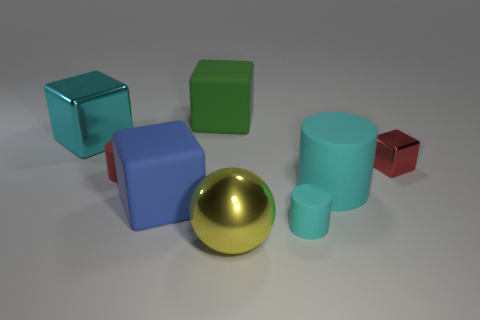Subtract all big blue rubber blocks. How many blocks are left? 3 Add 1 cyan metallic blocks. How many objects exist? 9 Subtract 1 balls. How many balls are left? 0 Subtract all cyan cubes. How many cubes are left? 3 Subtract all cylinders. How many objects are left? 5 Subtract all green blocks. How many cyan cylinders are left? 2 Add 1 blue rubber blocks. How many blue rubber blocks exist? 2 Subtract 0 purple cubes. How many objects are left? 8 Subtract all brown cubes. Subtract all brown spheres. How many cubes are left? 4 Subtract all small brown spheres. Subtract all blue things. How many objects are left? 7 